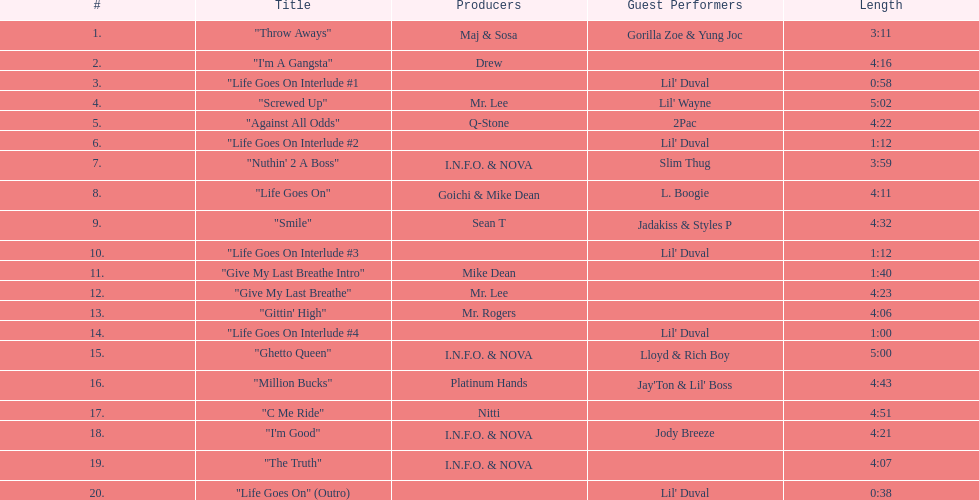How much time does the longest track on the album take? 5:02. 